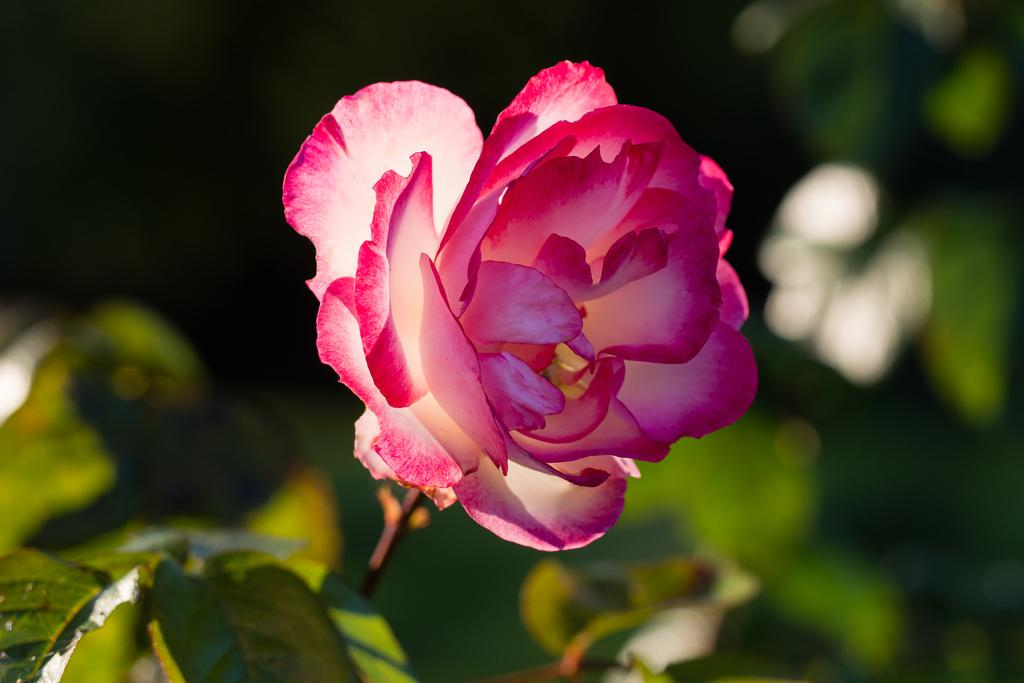What is the main subject of the image? There is a flower in the image. What else can be seen in the image besides the flower? There are leaves in the image. Can you describe the background of the image? The background of the image is blurry. How many fangs can be seen on the rat in the image? There is no rat present in the image, so it is not possible to determine the number of fangs. 